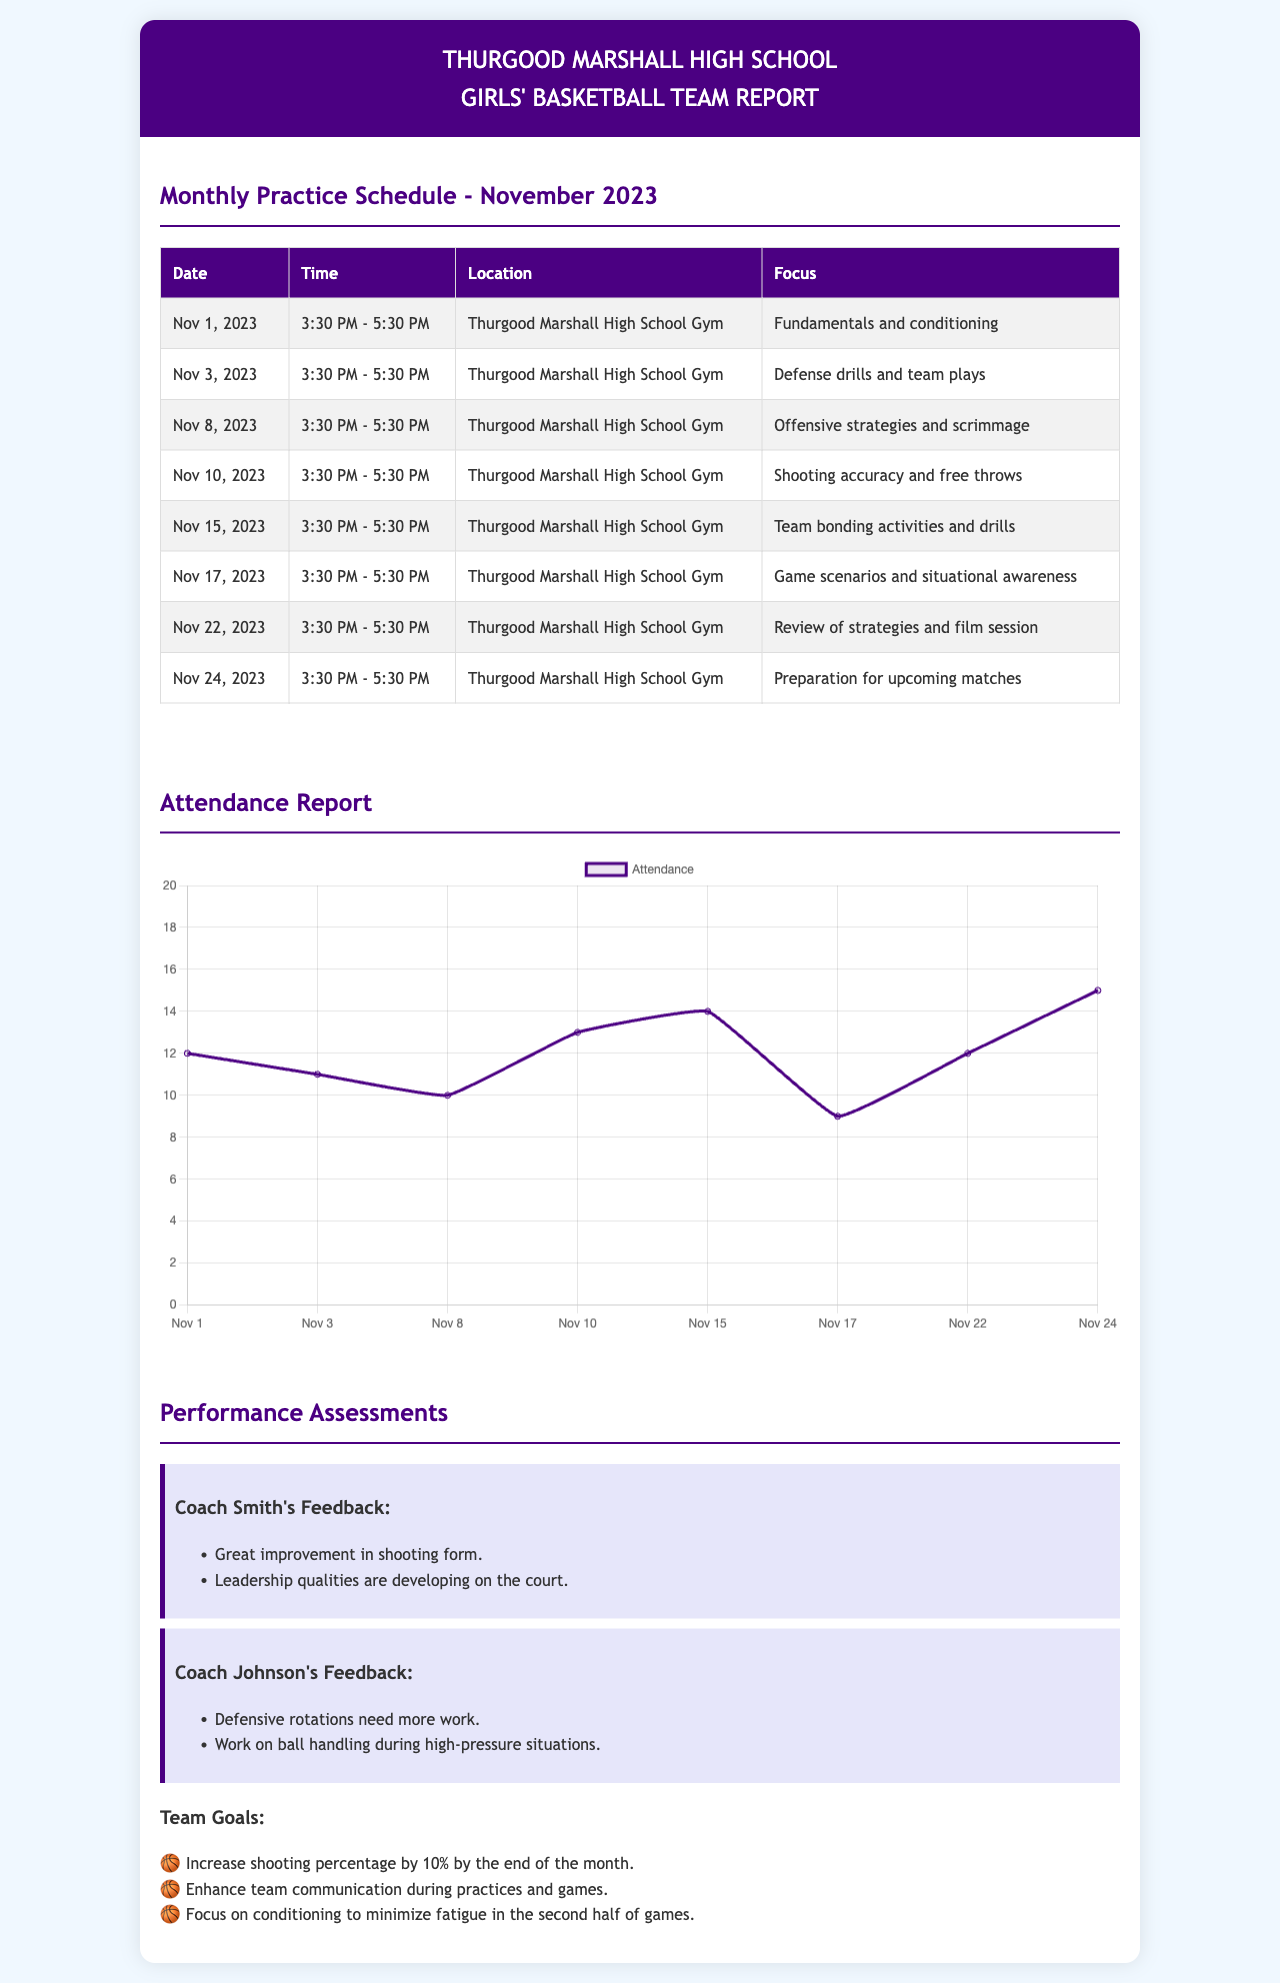What is the date of the first practice in November 2023? The first practice is listed in the schedule with the date of Nov 1, 2023.
Answer: Nov 1, 2023 What is the focus of the practice on November 10, 2023? The focus for this practice is noted as "Shooting accuracy and free throws."
Answer: Shooting accuracy and free throws How many practices are scheduled in November 2023? There are a total of 8 practices listed for the month of November 2023.
Answer: 8 What feedback did Coach Smith provide? Coach Smith mentioned "Great improvement in shooting form" and "Leadership qualities are developing on the court."
Answer: Great improvement in shooting form What is the attendance on November 17, 2023? The attendance for this date is recorded as 9 players in the attendance chart.
Answer: 9 What is one of the team goals for the month? One of the goals states "Increase shooting percentage by 10% by the end of the month."
Answer: Increase shooting percentage by 10% When is the practice focused on team bonding activities? The practice focusing on team bonding activities is scheduled for November 15, 2023.
Answer: Nov 15, 2023 Which location hosts all practices during November? The location mentioned for all practices is "Thurgood Marshall High School Gym."
Answer: Thurgood Marshall High School Gym 